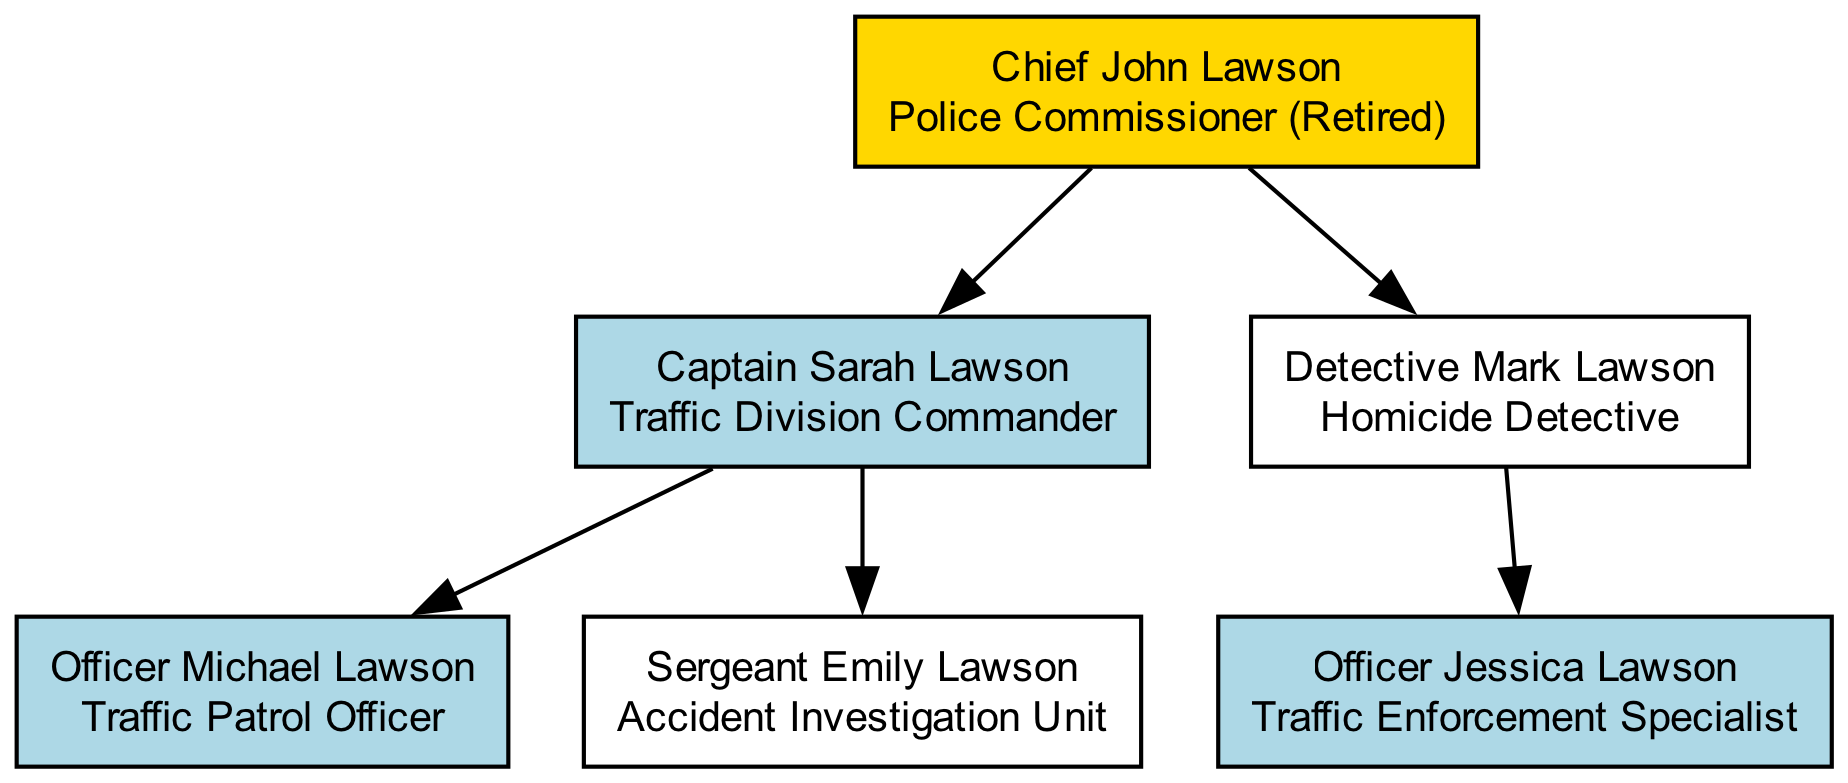What is the role of Chief John Lawson? The diagram shows that Chief John Lawson's role is "Police Commissioner (Retired)" as indicated in the label for this node.
Answer: Police Commissioner (Retired) How many children does Captain Sarah Lawson have? Looking at the diagram, Captain Sarah Lawson has two children: Officer Michael Lawson and Sergeant Emily Lawson. Therefore, the count is two.
Answer: 2 Which member of the family tree is in the Accident Investigation Unit? According to the diagram, Sergeant Emily Lawson is clearly labeled with the role "Accident Investigation Unit," thus she is the member in that role.
Answer: Sergeant Emily Lawson What is the relationship between Officer Jessica Lawson and Detective Mark Lawson? The structure of the family tree indicates that Officer Jessica Lawson is the child of Detective Mark Lawson, as indicated by the hierarchical arrangement in the diagram.
Answer: Child Which member has a direct role in Traffic Enforcement? Reviewing the diagram, Officer Jessica Lawson is labeled as "Traffic Enforcement Specialist," indicating she has a direct role in Traffic Enforcement.
Answer: Officer Jessica Lawson How many members of the family are involved in traffic policing? By examining the diagram, we can identify three members involved in traffic policing: Captain Sarah Lawson (Traffic Division Commander), Officer Michael Lawson (Traffic Patrol Officer), and Officer Jessica Lawson (Traffic Enforcement Specialist). Therefore, the total is three.
Answer: 3 What is the highest-ranking position in the family tree? The diagram indicates that Chief John Lawson holds the highest-ranking position as "Police Commissioner (Retired)," which is at the top of the hierarchy in the family tree.
Answer: Police Commissioner (Retired) Which generation does Sergeant Emily Lawson belong to? The diagram shows that Sergeant Emily Lawson is a child of Captain Sarah Lawson, who is a child of Chief John Lawson, placing her in the third generation of the family tree.
Answer: Third generation What color represents traffic-related roles in the diagram? According to the color coding described, traffic-related roles are represented by a light blue color in the diagram.
Answer: Light blue 